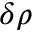Convert formula to latex. <formula><loc_0><loc_0><loc_500><loc_500>\delta \rho</formula> 